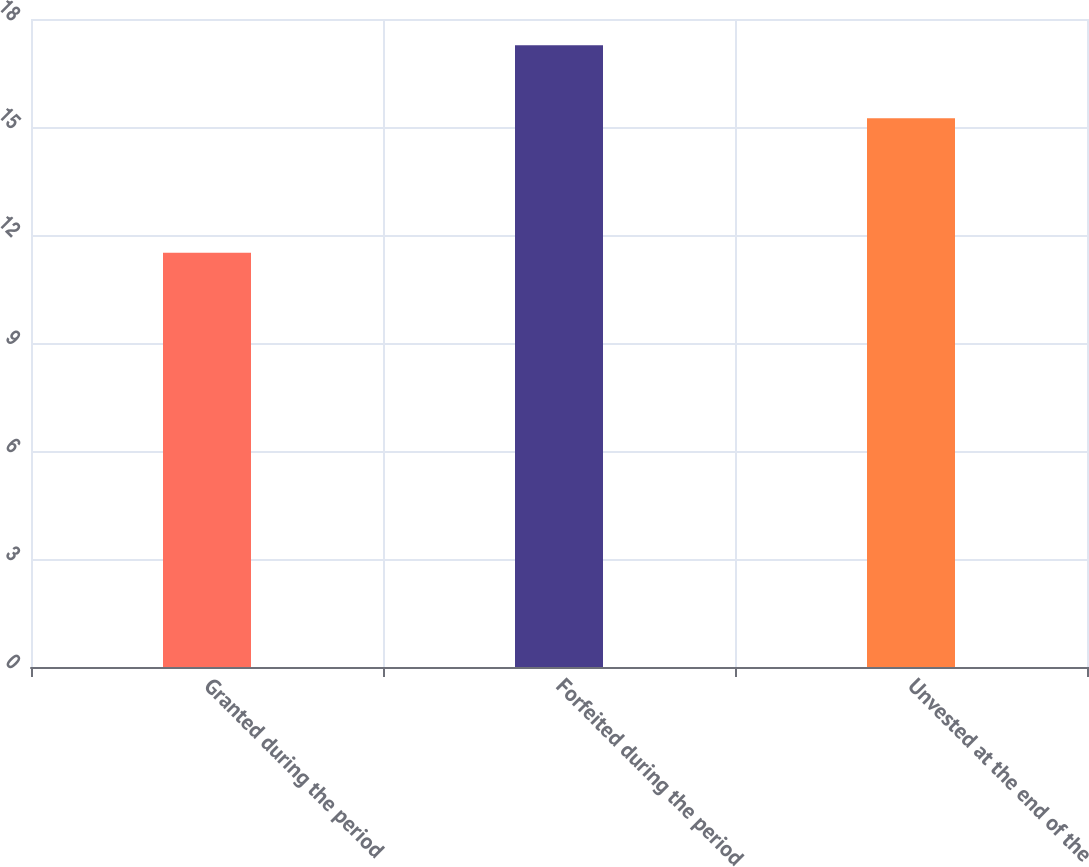<chart> <loc_0><loc_0><loc_500><loc_500><bar_chart><fcel>Granted during the period<fcel>Forfeited during the period<fcel>Unvested at the end of the<nl><fcel>11.51<fcel>17.27<fcel>15.24<nl></chart> 